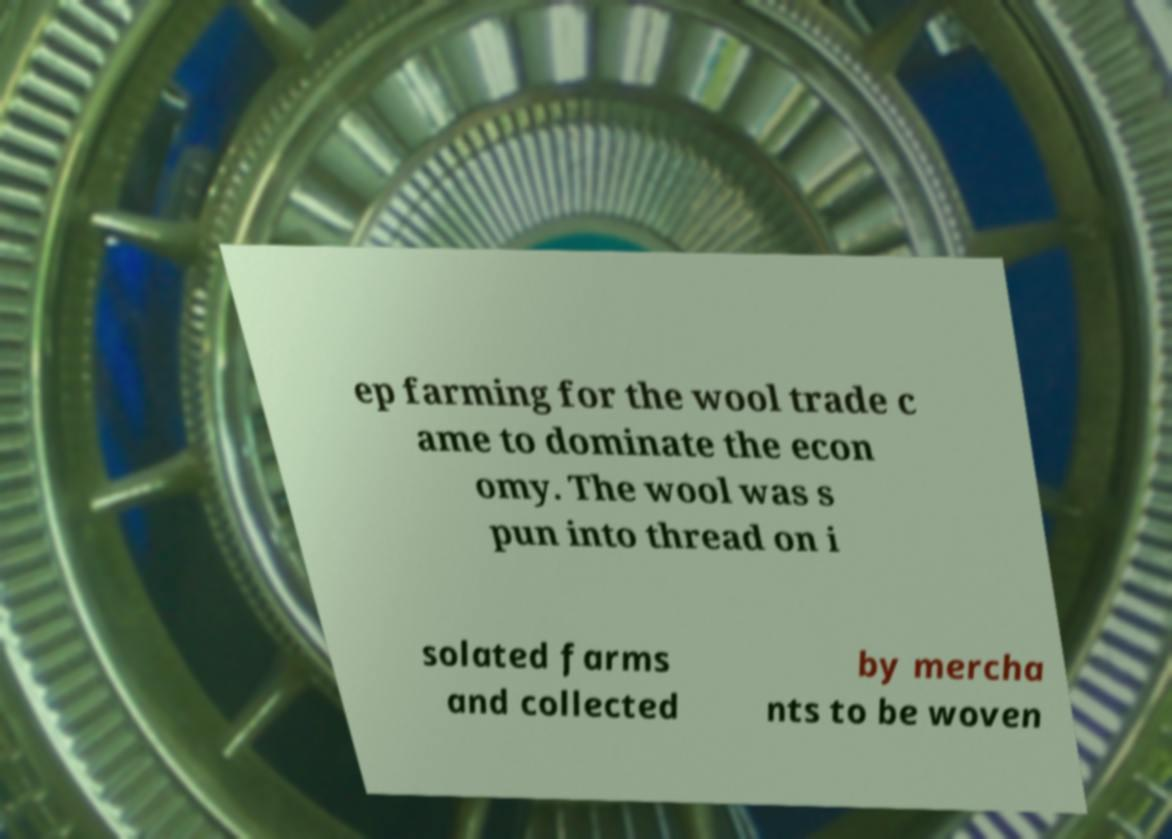Could you assist in decoding the text presented in this image and type it out clearly? ep farming for the wool trade c ame to dominate the econ omy. The wool was s pun into thread on i solated farms and collected by mercha nts to be woven 